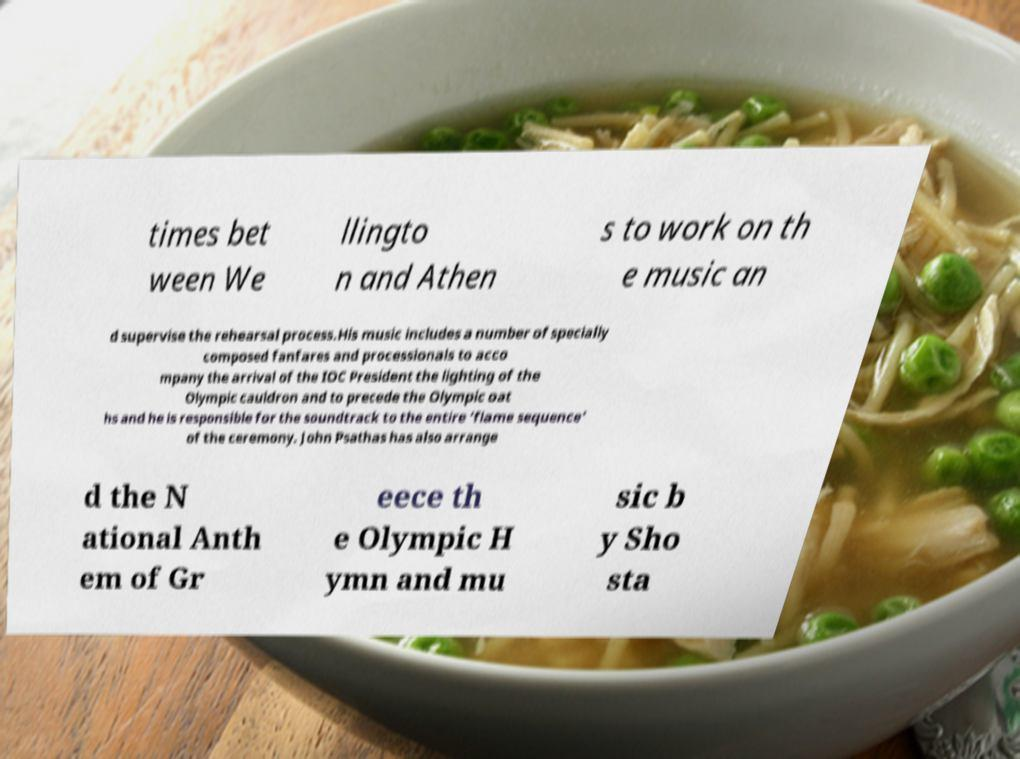Please read and relay the text visible in this image. What does it say? times bet ween We llingto n and Athen s to work on th e music an d supervise the rehearsal process.His music includes a number of specially composed fanfares and processionals to acco mpany the arrival of the IOC President the lighting of the Olympic cauldron and to precede the Olympic oat hs and he is responsible for the soundtrack to the entire ‘flame sequence’ of the ceremony. John Psathas has also arrange d the N ational Anth em of Gr eece th e Olympic H ymn and mu sic b y Sho sta 